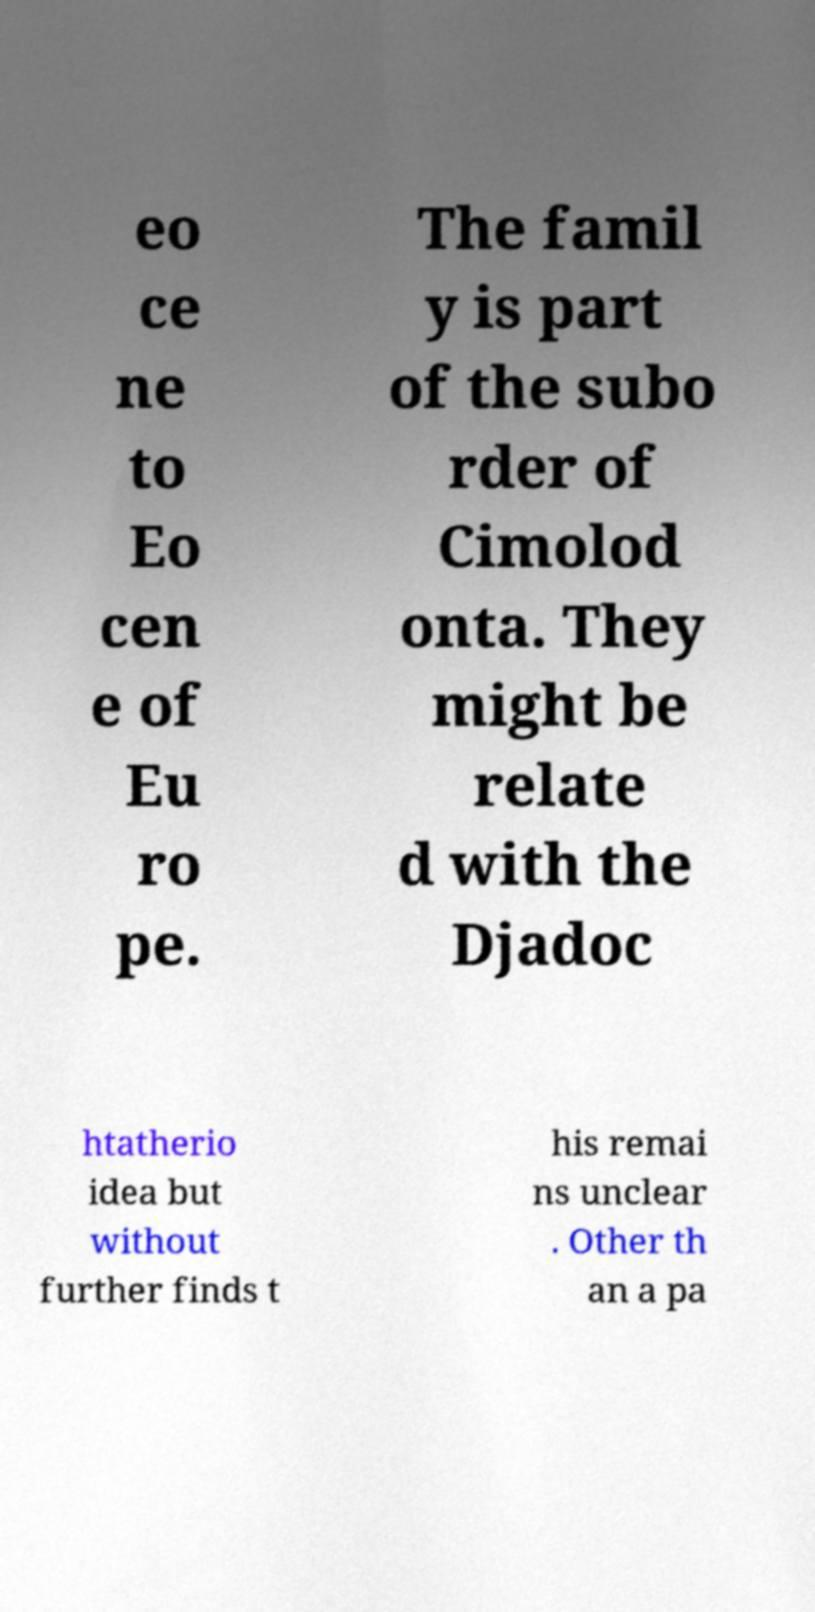There's text embedded in this image that I need extracted. Can you transcribe it verbatim? eo ce ne to Eo cen e of Eu ro pe. The famil y is part of the subo rder of Cimolod onta. They might be relate d with the Djadoc htatherio idea but without further finds t his remai ns unclear . Other th an a pa 